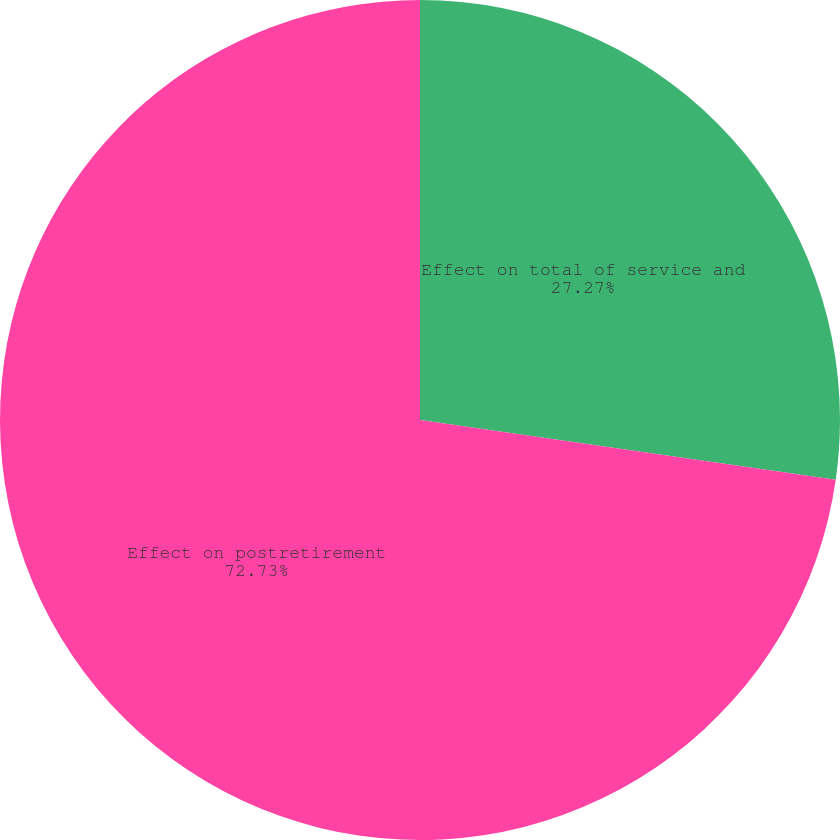<chart> <loc_0><loc_0><loc_500><loc_500><pie_chart><fcel>Effect on total of service and<fcel>Effect on postretirement<nl><fcel>27.27%<fcel>72.73%<nl></chart> 